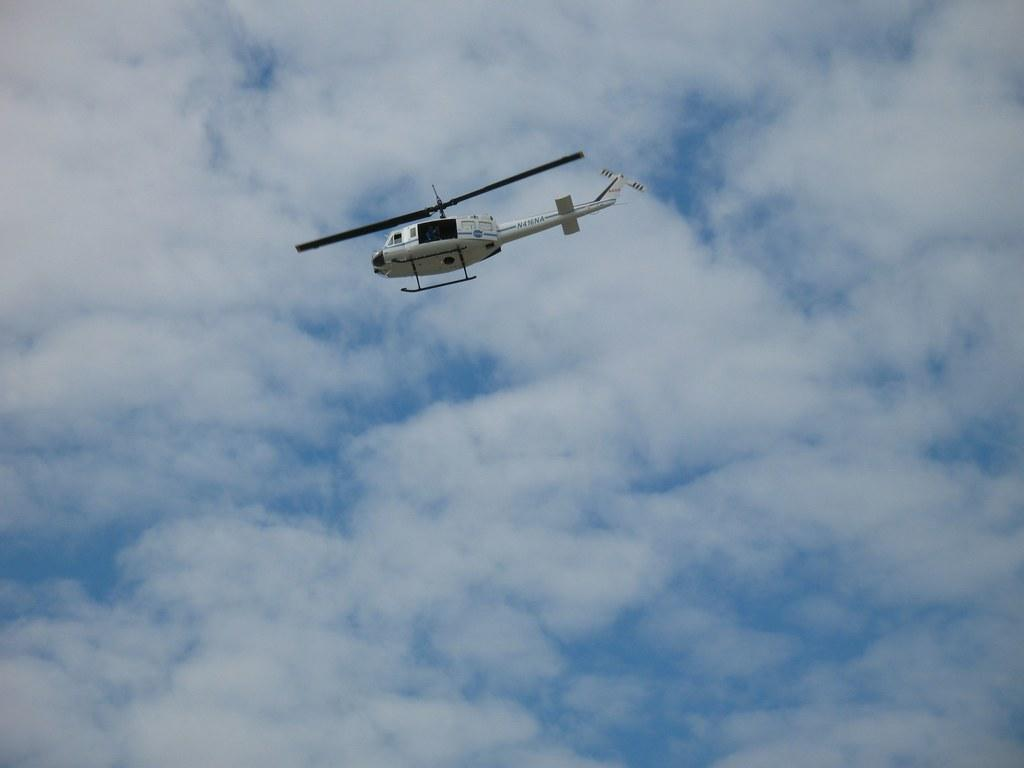What is the main subject of the image? The main subject of the image is a helicopter. What is the helicopter doing in the image? The helicopter is flying in the image. What can be seen in the background of the image? The sky is visible in the background of the image. What type of shoe can be seen hanging from the helicopter in the image? There is no shoe present in the image; it features of the helicopter are the focus. 